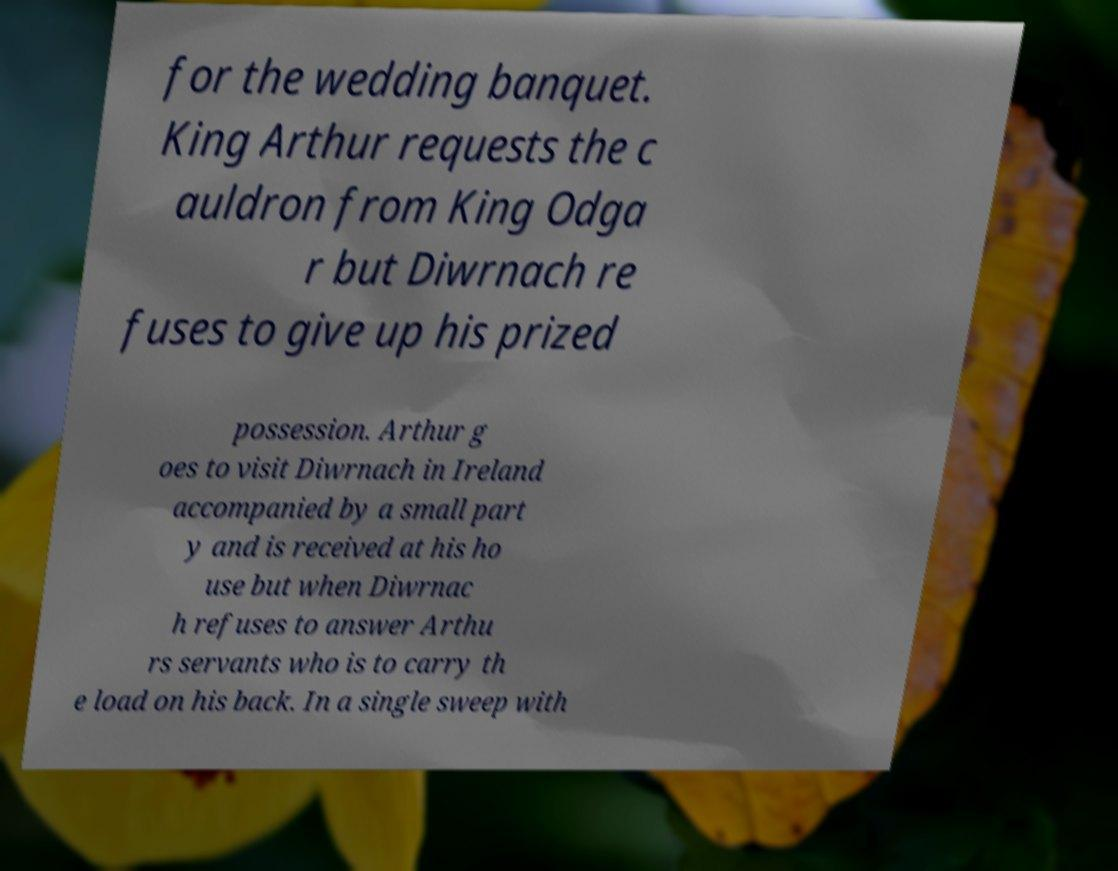Please read and relay the text visible in this image. What does it say? for the wedding banquet. King Arthur requests the c auldron from King Odga r but Diwrnach re fuses to give up his prized possession. Arthur g oes to visit Diwrnach in Ireland accompanied by a small part y and is received at his ho use but when Diwrnac h refuses to answer Arthu rs servants who is to carry th e load on his back. In a single sweep with 